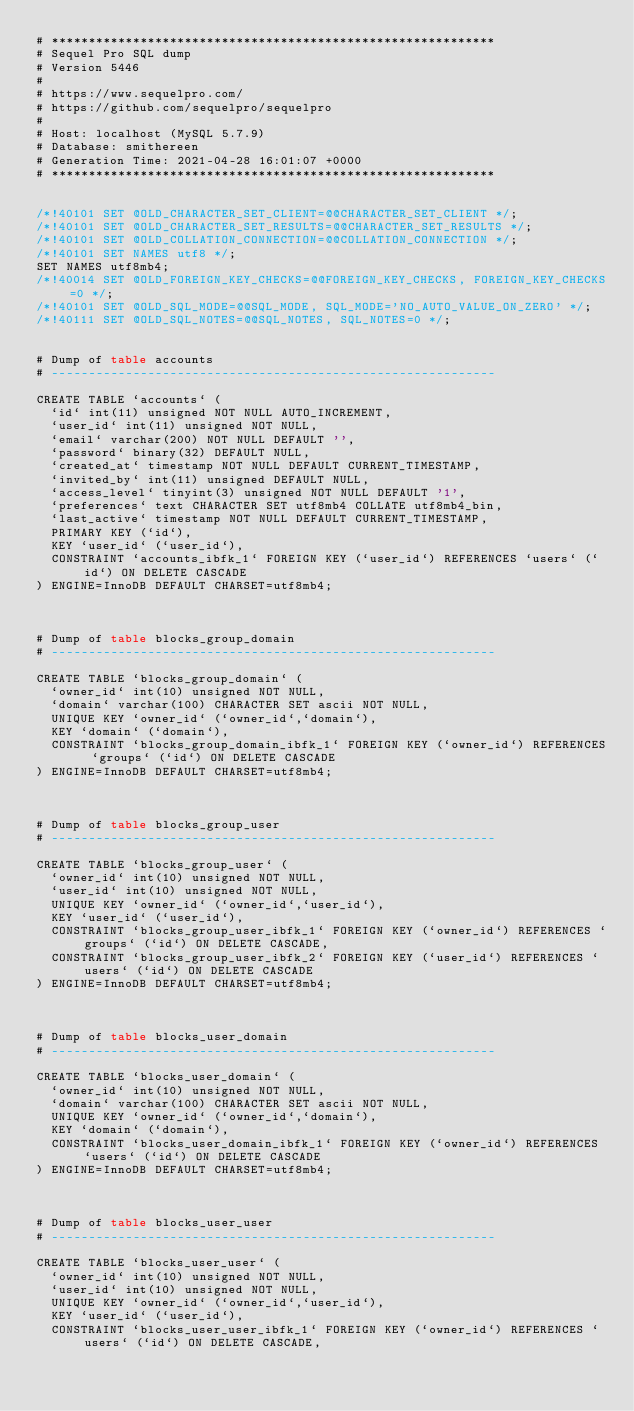Convert code to text. <code><loc_0><loc_0><loc_500><loc_500><_SQL_># ************************************************************
# Sequel Pro SQL dump
# Version 5446
#
# https://www.sequelpro.com/
# https://github.com/sequelpro/sequelpro
#
# Host: localhost (MySQL 5.7.9)
# Database: smithereen
# Generation Time: 2021-04-28 16:01:07 +0000
# ************************************************************


/*!40101 SET @OLD_CHARACTER_SET_CLIENT=@@CHARACTER_SET_CLIENT */;
/*!40101 SET @OLD_CHARACTER_SET_RESULTS=@@CHARACTER_SET_RESULTS */;
/*!40101 SET @OLD_COLLATION_CONNECTION=@@COLLATION_CONNECTION */;
/*!40101 SET NAMES utf8 */;
SET NAMES utf8mb4;
/*!40014 SET @OLD_FOREIGN_KEY_CHECKS=@@FOREIGN_KEY_CHECKS, FOREIGN_KEY_CHECKS=0 */;
/*!40101 SET @OLD_SQL_MODE=@@SQL_MODE, SQL_MODE='NO_AUTO_VALUE_ON_ZERO' */;
/*!40111 SET @OLD_SQL_NOTES=@@SQL_NOTES, SQL_NOTES=0 */;


# Dump of table accounts
# ------------------------------------------------------------

CREATE TABLE `accounts` (
  `id` int(11) unsigned NOT NULL AUTO_INCREMENT,
  `user_id` int(11) unsigned NOT NULL,
  `email` varchar(200) NOT NULL DEFAULT '',
  `password` binary(32) DEFAULT NULL,
  `created_at` timestamp NOT NULL DEFAULT CURRENT_TIMESTAMP,
  `invited_by` int(11) unsigned DEFAULT NULL,
  `access_level` tinyint(3) unsigned NOT NULL DEFAULT '1',
  `preferences` text CHARACTER SET utf8mb4 COLLATE utf8mb4_bin,
  `last_active` timestamp NOT NULL DEFAULT CURRENT_TIMESTAMP,
  PRIMARY KEY (`id`),
  KEY `user_id` (`user_id`),
  CONSTRAINT `accounts_ibfk_1` FOREIGN KEY (`user_id`) REFERENCES `users` (`id`) ON DELETE CASCADE
) ENGINE=InnoDB DEFAULT CHARSET=utf8mb4;



# Dump of table blocks_group_domain
# ------------------------------------------------------------

CREATE TABLE `blocks_group_domain` (
  `owner_id` int(10) unsigned NOT NULL,
  `domain` varchar(100) CHARACTER SET ascii NOT NULL,
  UNIQUE KEY `owner_id` (`owner_id`,`domain`),
  KEY `domain` (`domain`),
  CONSTRAINT `blocks_group_domain_ibfk_1` FOREIGN KEY (`owner_id`) REFERENCES `groups` (`id`) ON DELETE CASCADE
) ENGINE=InnoDB DEFAULT CHARSET=utf8mb4;



# Dump of table blocks_group_user
# ------------------------------------------------------------

CREATE TABLE `blocks_group_user` (
  `owner_id` int(10) unsigned NOT NULL,
  `user_id` int(10) unsigned NOT NULL,
  UNIQUE KEY `owner_id` (`owner_id`,`user_id`),
  KEY `user_id` (`user_id`),
  CONSTRAINT `blocks_group_user_ibfk_1` FOREIGN KEY (`owner_id`) REFERENCES `groups` (`id`) ON DELETE CASCADE,
  CONSTRAINT `blocks_group_user_ibfk_2` FOREIGN KEY (`user_id`) REFERENCES `users` (`id`) ON DELETE CASCADE
) ENGINE=InnoDB DEFAULT CHARSET=utf8mb4;



# Dump of table blocks_user_domain
# ------------------------------------------------------------

CREATE TABLE `blocks_user_domain` (
  `owner_id` int(10) unsigned NOT NULL,
  `domain` varchar(100) CHARACTER SET ascii NOT NULL,
  UNIQUE KEY `owner_id` (`owner_id`,`domain`),
  KEY `domain` (`domain`),
  CONSTRAINT `blocks_user_domain_ibfk_1` FOREIGN KEY (`owner_id`) REFERENCES `users` (`id`) ON DELETE CASCADE
) ENGINE=InnoDB DEFAULT CHARSET=utf8mb4;



# Dump of table blocks_user_user
# ------------------------------------------------------------

CREATE TABLE `blocks_user_user` (
  `owner_id` int(10) unsigned NOT NULL,
  `user_id` int(10) unsigned NOT NULL,
  UNIQUE KEY `owner_id` (`owner_id`,`user_id`),
  KEY `user_id` (`user_id`),
  CONSTRAINT `blocks_user_user_ibfk_1` FOREIGN KEY (`owner_id`) REFERENCES `users` (`id`) ON DELETE CASCADE,</code> 